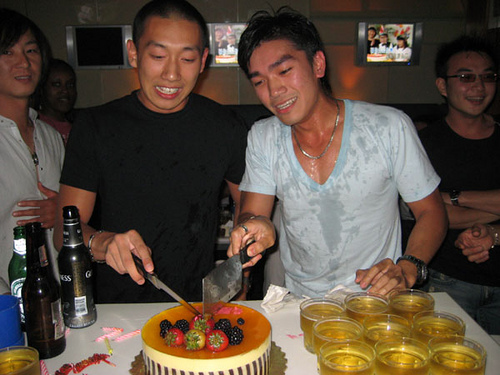What is the expression of the person in the black shirt? The person in the black shirt appears to be smiling, suggesting he is happy and enjoying the celebration. What are the items present on the table? On the table, there are several cups of what appears to be beer, some beer bottles, an orange-colored cake decorated with fruits, and a large knife for cutting the cake. Describe the possible setting of this gathering. This gathering is likely taking place in a casual setting such as a home or a private party room, given the intimate crowd and the assortment of personal beverages and snacks. The focus seems to be on enjoying good company and celebrating a special occasion. Imagine you're the host of this party. Write an elaborate plan for the night's events. As the host, the night starts with a warm welcome and introductions, followed by casual conversations and background music to set a relaxed atmosphere. Soon, appetizers and drinks are served while guests mingle and catch up. A couple of fun games or activities are arranged to break the ice and boost the energy. Dinner is served buffet-style, allowing everyone to help themselves to a variety of dishes. As the evening draws on, the cake-cutting ceremony takes center stage, where everyone gathers around, singing and celebrating. Post-cake cutting, more lively music and dancing keep the energy high. To wrap up, a heartfelt toast is made, thanking everyone for coming and making the night memorable. 